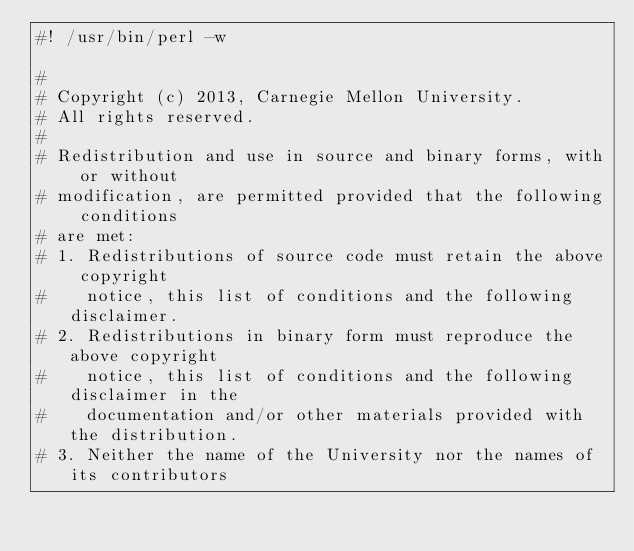Convert code to text. <code><loc_0><loc_0><loc_500><loc_500><_Perl_>#! /usr/bin/perl -w

#
# Copyright (c) 2013, Carnegie Mellon University.
# All rights reserved.
#
# Redistribution and use in source and binary forms, with or without
# modification, are permitted provided that the following conditions
# are met:
# 1. Redistributions of source code must retain the above copyright
#    notice, this list of conditions and the following disclaimer.
# 2. Redistributions in binary form must reproduce the above copyright
#    notice, this list of conditions and the following disclaimer in the
#    documentation and/or other materials provided with the distribution.
# 3. Neither the name of the University nor the names of its contributors</code> 